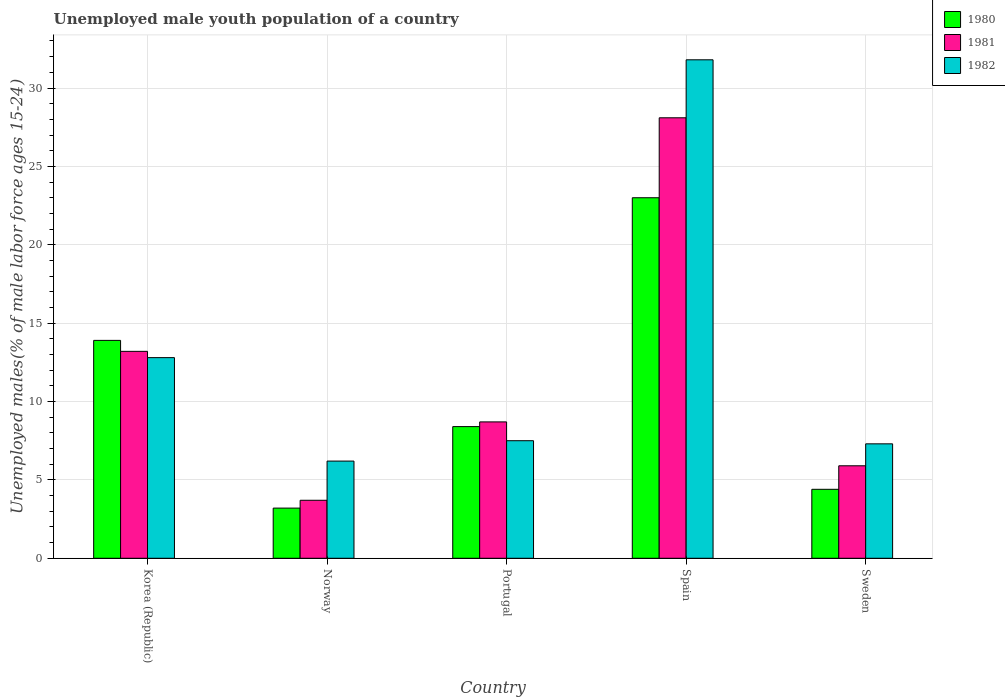How many groups of bars are there?
Provide a succinct answer. 5. Are the number of bars per tick equal to the number of legend labels?
Your answer should be compact. Yes. Are the number of bars on each tick of the X-axis equal?
Provide a succinct answer. Yes. What is the label of the 2nd group of bars from the left?
Provide a short and direct response. Norway. In how many cases, is the number of bars for a given country not equal to the number of legend labels?
Provide a succinct answer. 0. What is the percentage of unemployed male youth population in 1980 in Sweden?
Your answer should be compact. 4.4. Across all countries, what is the maximum percentage of unemployed male youth population in 1982?
Give a very brief answer. 31.8. Across all countries, what is the minimum percentage of unemployed male youth population in 1980?
Your response must be concise. 3.2. In which country was the percentage of unemployed male youth population in 1982 maximum?
Keep it short and to the point. Spain. What is the total percentage of unemployed male youth population in 1981 in the graph?
Give a very brief answer. 59.6. What is the difference between the percentage of unemployed male youth population in 1981 in Spain and that in Sweden?
Give a very brief answer. 22.2. What is the difference between the percentage of unemployed male youth population in 1982 in Korea (Republic) and the percentage of unemployed male youth population in 1980 in Spain?
Ensure brevity in your answer.  -10.2. What is the average percentage of unemployed male youth population in 1980 per country?
Give a very brief answer. 10.58. What is the difference between the percentage of unemployed male youth population of/in 1981 and percentage of unemployed male youth population of/in 1982 in Norway?
Your response must be concise. -2.5. In how many countries, is the percentage of unemployed male youth population in 1980 greater than 12 %?
Make the answer very short. 2. What is the ratio of the percentage of unemployed male youth population in 1980 in Norway to that in Sweden?
Keep it short and to the point. 0.73. What is the difference between the highest and the second highest percentage of unemployed male youth population in 1981?
Offer a terse response. -19.4. What is the difference between the highest and the lowest percentage of unemployed male youth population in 1980?
Offer a terse response. 19.8. Is the sum of the percentage of unemployed male youth population in 1981 in Norway and Portugal greater than the maximum percentage of unemployed male youth population in 1980 across all countries?
Make the answer very short. No. What does the 1st bar from the left in Norway represents?
Offer a very short reply. 1980. What does the 1st bar from the right in Sweden represents?
Your answer should be compact. 1982. How many bars are there?
Provide a succinct answer. 15. Are all the bars in the graph horizontal?
Make the answer very short. No. What is the difference between two consecutive major ticks on the Y-axis?
Your answer should be very brief. 5. Are the values on the major ticks of Y-axis written in scientific E-notation?
Ensure brevity in your answer.  No. Does the graph contain grids?
Keep it short and to the point. Yes. Where does the legend appear in the graph?
Give a very brief answer. Top right. How are the legend labels stacked?
Offer a very short reply. Vertical. What is the title of the graph?
Your response must be concise. Unemployed male youth population of a country. What is the label or title of the Y-axis?
Keep it short and to the point. Unemployed males(% of male labor force ages 15-24). What is the Unemployed males(% of male labor force ages 15-24) of 1980 in Korea (Republic)?
Make the answer very short. 13.9. What is the Unemployed males(% of male labor force ages 15-24) in 1981 in Korea (Republic)?
Provide a short and direct response. 13.2. What is the Unemployed males(% of male labor force ages 15-24) in 1982 in Korea (Republic)?
Give a very brief answer. 12.8. What is the Unemployed males(% of male labor force ages 15-24) of 1980 in Norway?
Your answer should be very brief. 3.2. What is the Unemployed males(% of male labor force ages 15-24) of 1981 in Norway?
Give a very brief answer. 3.7. What is the Unemployed males(% of male labor force ages 15-24) of 1982 in Norway?
Keep it short and to the point. 6.2. What is the Unemployed males(% of male labor force ages 15-24) of 1980 in Portugal?
Keep it short and to the point. 8.4. What is the Unemployed males(% of male labor force ages 15-24) of 1981 in Portugal?
Keep it short and to the point. 8.7. What is the Unemployed males(% of male labor force ages 15-24) of 1982 in Portugal?
Offer a terse response. 7.5. What is the Unemployed males(% of male labor force ages 15-24) in 1980 in Spain?
Your response must be concise. 23. What is the Unemployed males(% of male labor force ages 15-24) of 1981 in Spain?
Offer a very short reply. 28.1. What is the Unemployed males(% of male labor force ages 15-24) in 1982 in Spain?
Make the answer very short. 31.8. What is the Unemployed males(% of male labor force ages 15-24) in 1980 in Sweden?
Make the answer very short. 4.4. What is the Unemployed males(% of male labor force ages 15-24) in 1981 in Sweden?
Give a very brief answer. 5.9. What is the Unemployed males(% of male labor force ages 15-24) of 1982 in Sweden?
Offer a terse response. 7.3. Across all countries, what is the maximum Unemployed males(% of male labor force ages 15-24) of 1980?
Provide a succinct answer. 23. Across all countries, what is the maximum Unemployed males(% of male labor force ages 15-24) of 1981?
Your answer should be very brief. 28.1. Across all countries, what is the maximum Unemployed males(% of male labor force ages 15-24) of 1982?
Keep it short and to the point. 31.8. Across all countries, what is the minimum Unemployed males(% of male labor force ages 15-24) in 1980?
Make the answer very short. 3.2. Across all countries, what is the minimum Unemployed males(% of male labor force ages 15-24) in 1981?
Ensure brevity in your answer.  3.7. Across all countries, what is the minimum Unemployed males(% of male labor force ages 15-24) of 1982?
Offer a very short reply. 6.2. What is the total Unemployed males(% of male labor force ages 15-24) in 1980 in the graph?
Your answer should be compact. 52.9. What is the total Unemployed males(% of male labor force ages 15-24) in 1981 in the graph?
Make the answer very short. 59.6. What is the total Unemployed males(% of male labor force ages 15-24) of 1982 in the graph?
Provide a short and direct response. 65.6. What is the difference between the Unemployed males(% of male labor force ages 15-24) of 1980 in Korea (Republic) and that in Norway?
Offer a terse response. 10.7. What is the difference between the Unemployed males(% of male labor force ages 15-24) in 1982 in Korea (Republic) and that in Norway?
Keep it short and to the point. 6.6. What is the difference between the Unemployed males(% of male labor force ages 15-24) of 1981 in Korea (Republic) and that in Portugal?
Offer a very short reply. 4.5. What is the difference between the Unemployed males(% of male labor force ages 15-24) in 1982 in Korea (Republic) and that in Portugal?
Provide a short and direct response. 5.3. What is the difference between the Unemployed males(% of male labor force ages 15-24) in 1981 in Korea (Republic) and that in Spain?
Offer a very short reply. -14.9. What is the difference between the Unemployed males(% of male labor force ages 15-24) in 1982 in Korea (Republic) and that in Spain?
Give a very brief answer. -19. What is the difference between the Unemployed males(% of male labor force ages 15-24) of 1980 in Korea (Republic) and that in Sweden?
Your answer should be very brief. 9.5. What is the difference between the Unemployed males(% of male labor force ages 15-24) in 1982 in Korea (Republic) and that in Sweden?
Ensure brevity in your answer.  5.5. What is the difference between the Unemployed males(% of male labor force ages 15-24) in 1980 in Norway and that in Spain?
Provide a succinct answer. -19.8. What is the difference between the Unemployed males(% of male labor force ages 15-24) in 1981 in Norway and that in Spain?
Ensure brevity in your answer.  -24.4. What is the difference between the Unemployed males(% of male labor force ages 15-24) of 1982 in Norway and that in Spain?
Your answer should be compact. -25.6. What is the difference between the Unemployed males(% of male labor force ages 15-24) of 1982 in Norway and that in Sweden?
Offer a very short reply. -1.1. What is the difference between the Unemployed males(% of male labor force ages 15-24) in 1980 in Portugal and that in Spain?
Your answer should be compact. -14.6. What is the difference between the Unemployed males(% of male labor force ages 15-24) in 1981 in Portugal and that in Spain?
Your response must be concise. -19.4. What is the difference between the Unemployed males(% of male labor force ages 15-24) of 1982 in Portugal and that in Spain?
Ensure brevity in your answer.  -24.3. What is the difference between the Unemployed males(% of male labor force ages 15-24) of 1980 in Portugal and that in Sweden?
Make the answer very short. 4. What is the difference between the Unemployed males(% of male labor force ages 15-24) of 1981 in Portugal and that in Sweden?
Keep it short and to the point. 2.8. What is the difference between the Unemployed males(% of male labor force ages 15-24) in 1982 in Portugal and that in Sweden?
Your response must be concise. 0.2. What is the difference between the Unemployed males(% of male labor force ages 15-24) in 1982 in Spain and that in Sweden?
Give a very brief answer. 24.5. What is the difference between the Unemployed males(% of male labor force ages 15-24) of 1980 in Korea (Republic) and the Unemployed males(% of male labor force ages 15-24) of 1982 in Norway?
Provide a short and direct response. 7.7. What is the difference between the Unemployed males(% of male labor force ages 15-24) of 1980 in Korea (Republic) and the Unemployed males(% of male labor force ages 15-24) of 1981 in Portugal?
Your response must be concise. 5.2. What is the difference between the Unemployed males(% of male labor force ages 15-24) in 1981 in Korea (Republic) and the Unemployed males(% of male labor force ages 15-24) in 1982 in Portugal?
Offer a terse response. 5.7. What is the difference between the Unemployed males(% of male labor force ages 15-24) in 1980 in Korea (Republic) and the Unemployed males(% of male labor force ages 15-24) in 1981 in Spain?
Offer a very short reply. -14.2. What is the difference between the Unemployed males(% of male labor force ages 15-24) in 1980 in Korea (Republic) and the Unemployed males(% of male labor force ages 15-24) in 1982 in Spain?
Your answer should be compact. -17.9. What is the difference between the Unemployed males(% of male labor force ages 15-24) in 1981 in Korea (Republic) and the Unemployed males(% of male labor force ages 15-24) in 1982 in Spain?
Keep it short and to the point. -18.6. What is the difference between the Unemployed males(% of male labor force ages 15-24) in 1980 in Korea (Republic) and the Unemployed males(% of male labor force ages 15-24) in 1982 in Sweden?
Provide a short and direct response. 6.6. What is the difference between the Unemployed males(% of male labor force ages 15-24) of 1981 in Korea (Republic) and the Unemployed males(% of male labor force ages 15-24) of 1982 in Sweden?
Ensure brevity in your answer.  5.9. What is the difference between the Unemployed males(% of male labor force ages 15-24) in 1981 in Norway and the Unemployed males(% of male labor force ages 15-24) in 1982 in Portugal?
Provide a succinct answer. -3.8. What is the difference between the Unemployed males(% of male labor force ages 15-24) in 1980 in Norway and the Unemployed males(% of male labor force ages 15-24) in 1981 in Spain?
Offer a very short reply. -24.9. What is the difference between the Unemployed males(% of male labor force ages 15-24) in 1980 in Norway and the Unemployed males(% of male labor force ages 15-24) in 1982 in Spain?
Keep it short and to the point. -28.6. What is the difference between the Unemployed males(% of male labor force ages 15-24) in 1981 in Norway and the Unemployed males(% of male labor force ages 15-24) in 1982 in Spain?
Provide a short and direct response. -28.1. What is the difference between the Unemployed males(% of male labor force ages 15-24) in 1980 in Norway and the Unemployed males(% of male labor force ages 15-24) in 1982 in Sweden?
Offer a terse response. -4.1. What is the difference between the Unemployed males(% of male labor force ages 15-24) in 1980 in Portugal and the Unemployed males(% of male labor force ages 15-24) in 1981 in Spain?
Your answer should be very brief. -19.7. What is the difference between the Unemployed males(% of male labor force ages 15-24) in 1980 in Portugal and the Unemployed males(% of male labor force ages 15-24) in 1982 in Spain?
Make the answer very short. -23.4. What is the difference between the Unemployed males(% of male labor force ages 15-24) in 1981 in Portugal and the Unemployed males(% of male labor force ages 15-24) in 1982 in Spain?
Your answer should be very brief. -23.1. What is the difference between the Unemployed males(% of male labor force ages 15-24) in 1980 in Portugal and the Unemployed males(% of male labor force ages 15-24) in 1981 in Sweden?
Your answer should be very brief. 2.5. What is the difference between the Unemployed males(% of male labor force ages 15-24) in 1980 in Portugal and the Unemployed males(% of male labor force ages 15-24) in 1982 in Sweden?
Provide a short and direct response. 1.1. What is the difference between the Unemployed males(% of male labor force ages 15-24) of 1981 in Portugal and the Unemployed males(% of male labor force ages 15-24) of 1982 in Sweden?
Give a very brief answer. 1.4. What is the difference between the Unemployed males(% of male labor force ages 15-24) of 1980 in Spain and the Unemployed males(% of male labor force ages 15-24) of 1981 in Sweden?
Keep it short and to the point. 17.1. What is the difference between the Unemployed males(% of male labor force ages 15-24) of 1980 in Spain and the Unemployed males(% of male labor force ages 15-24) of 1982 in Sweden?
Your answer should be very brief. 15.7. What is the difference between the Unemployed males(% of male labor force ages 15-24) in 1981 in Spain and the Unemployed males(% of male labor force ages 15-24) in 1982 in Sweden?
Keep it short and to the point. 20.8. What is the average Unemployed males(% of male labor force ages 15-24) of 1980 per country?
Make the answer very short. 10.58. What is the average Unemployed males(% of male labor force ages 15-24) in 1981 per country?
Provide a short and direct response. 11.92. What is the average Unemployed males(% of male labor force ages 15-24) of 1982 per country?
Provide a succinct answer. 13.12. What is the difference between the Unemployed males(% of male labor force ages 15-24) in 1980 and Unemployed males(% of male labor force ages 15-24) in 1982 in Korea (Republic)?
Provide a short and direct response. 1.1. What is the difference between the Unemployed males(% of male labor force ages 15-24) in 1980 and Unemployed males(% of male labor force ages 15-24) in 1981 in Portugal?
Offer a terse response. -0.3. What is the difference between the Unemployed males(% of male labor force ages 15-24) in 1981 and Unemployed males(% of male labor force ages 15-24) in 1982 in Portugal?
Offer a terse response. 1.2. What is the difference between the Unemployed males(% of male labor force ages 15-24) in 1980 and Unemployed males(% of male labor force ages 15-24) in 1981 in Spain?
Give a very brief answer. -5.1. What is the difference between the Unemployed males(% of male labor force ages 15-24) of 1980 and Unemployed males(% of male labor force ages 15-24) of 1982 in Spain?
Your response must be concise. -8.8. What is the difference between the Unemployed males(% of male labor force ages 15-24) of 1981 and Unemployed males(% of male labor force ages 15-24) of 1982 in Spain?
Give a very brief answer. -3.7. What is the difference between the Unemployed males(% of male labor force ages 15-24) of 1980 and Unemployed males(% of male labor force ages 15-24) of 1981 in Sweden?
Ensure brevity in your answer.  -1.5. What is the ratio of the Unemployed males(% of male labor force ages 15-24) in 1980 in Korea (Republic) to that in Norway?
Offer a very short reply. 4.34. What is the ratio of the Unemployed males(% of male labor force ages 15-24) in 1981 in Korea (Republic) to that in Norway?
Your answer should be compact. 3.57. What is the ratio of the Unemployed males(% of male labor force ages 15-24) in 1982 in Korea (Republic) to that in Norway?
Keep it short and to the point. 2.06. What is the ratio of the Unemployed males(% of male labor force ages 15-24) in 1980 in Korea (Republic) to that in Portugal?
Offer a very short reply. 1.65. What is the ratio of the Unemployed males(% of male labor force ages 15-24) in 1981 in Korea (Republic) to that in Portugal?
Provide a short and direct response. 1.52. What is the ratio of the Unemployed males(% of male labor force ages 15-24) of 1982 in Korea (Republic) to that in Portugal?
Ensure brevity in your answer.  1.71. What is the ratio of the Unemployed males(% of male labor force ages 15-24) of 1980 in Korea (Republic) to that in Spain?
Offer a very short reply. 0.6. What is the ratio of the Unemployed males(% of male labor force ages 15-24) of 1981 in Korea (Republic) to that in Spain?
Offer a very short reply. 0.47. What is the ratio of the Unemployed males(% of male labor force ages 15-24) in 1982 in Korea (Republic) to that in Spain?
Your response must be concise. 0.4. What is the ratio of the Unemployed males(% of male labor force ages 15-24) in 1980 in Korea (Republic) to that in Sweden?
Give a very brief answer. 3.16. What is the ratio of the Unemployed males(% of male labor force ages 15-24) in 1981 in Korea (Republic) to that in Sweden?
Make the answer very short. 2.24. What is the ratio of the Unemployed males(% of male labor force ages 15-24) of 1982 in Korea (Republic) to that in Sweden?
Your answer should be very brief. 1.75. What is the ratio of the Unemployed males(% of male labor force ages 15-24) in 1980 in Norway to that in Portugal?
Your response must be concise. 0.38. What is the ratio of the Unemployed males(% of male labor force ages 15-24) of 1981 in Norway to that in Portugal?
Provide a succinct answer. 0.43. What is the ratio of the Unemployed males(% of male labor force ages 15-24) in 1982 in Norway to that in Portugal?
Offer a terse response. 0.83. What is the ratio of the Unemployed males(% of male labor force ages 15-24) in 1980 in Norway to that in Spain?
Your answer should be compact. 0.14. What is the ratio of the Unemployed males(% of male labor force ages 15-24) of 1981 in Norway to that in Spain?
Make the answer very short. 0.13. What is the ratio of the Unemployed males(% of male labor force ages 15-24) of 1982 in Norway to that in Spain?
Make the answer very short. 0.2. What is the ratio of the Unemployed males(% of male labor force ages 15-24) in 1980 in Norway to that in Sweden?
Offer a very short reply. 0.73. What is the ratio of the Unemployed males(% of male labor force ages 15-24) of 1981 in Norway to that in Sweden?
Give a very brief answer. 0.63. What is the ratio of the Unemployed males(% of male labor force ages 15-24) of 1982 in Norway to that in Sweden?
Your answer should be compact. 0.85. What is the ratio of the Unemployed males(% of male labor force ages 15-24) of 1980 in Portugal to that in Spain?
Provide a short and direct response. 0.37. What is the ratio of the Unemployed males(% of male labor force ages 15-24) in 1981 in Portugal to that in Spain?
Ensure brevity in your answer.  0.31. What is the ratio of the Unemployed males(% of male labor force ages 15-24) of 1982 in Portugal to that in Spain?
Keep it short and to the point. 0.24. What is the ratio of the Unemployed males(% of male labor force ages 15-24) in 1980 in Portugal to that in Sweden?
Your answer should be very brief. 1.91. What is the ratio of the Unemployed males(% of male labor force ages 15-24) of 1981 in Portugal to that in Sweden?
Ensure brevity in your answer.  1.47. What is the ratio of the Unemployed males(% of male labor force ages 15-24) of 1982 in Portugal to that in Sweden?
Ensure brevity in your answer.  1.03. What is the ratio of the Unemployed males(% of male labor force ages 15-24) of 1980 in Spain to that in Sweden?
Keep it short and to the point. 5.23. What is the ratio of the Unemployed males(% of male labor force ages 15-24) in 1981 in Spain to that in Sweden?
Offer a terse response. 4.76. What is the ratio of the Unemployed males(% of male labor force ages 15-24) in 1982 in Spain to that in Sweden?
Give a very brief answer. 4.36. What is the difference between the highest and the second highest Unemployed males(% of male labor force ages 15-24) in 1982?
Provide a short and direct response. 19. What is the difference between the highest and the lowest Unemployed males(% of male labor force ages 15-24) of 1980?
Offer a very short reply. 19.8. What is the difference between the highest and the lowest Unemployed males(% of male labor force ages 15-24) in 1981?
Offer a very short reply. 24.4. What is the difference between the highest and the lowest Unemployed males(% of male labor force ages 15-24) in 1982?
Offer a very short reply. 25.6. 